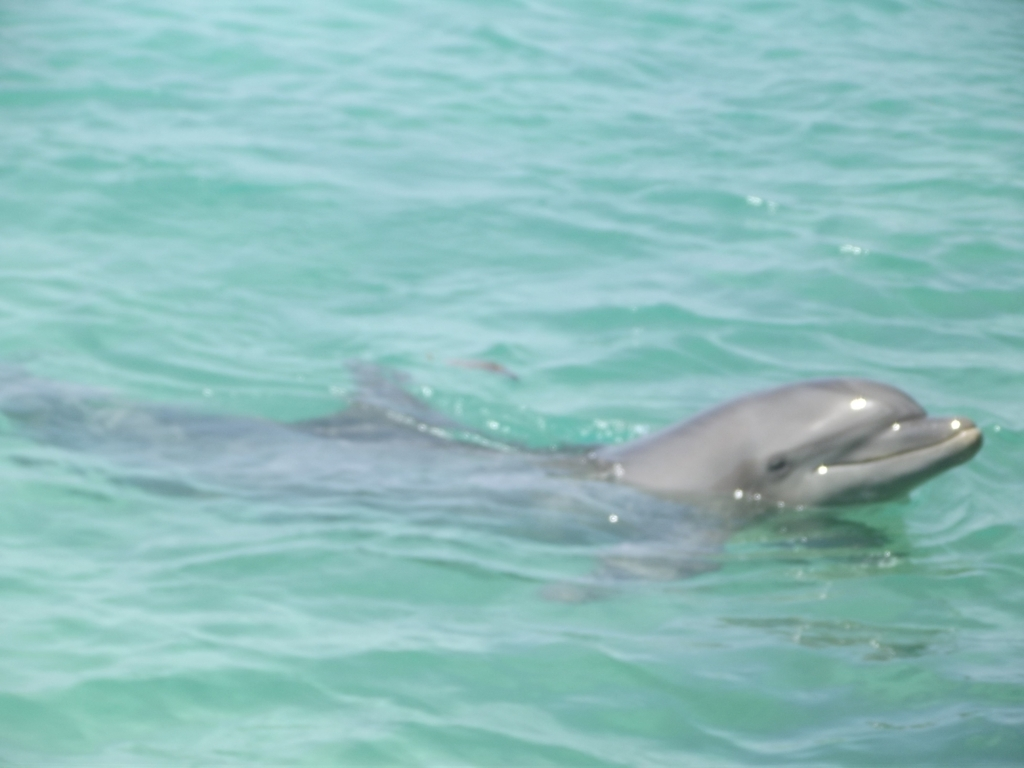Are there any major exposure issues in the photo? The image appears somewhat overexposed with a slight lack of focus, particularly noticeable around the dolphin and the water's surface which causes a slight washout in detail. The overall composition is still pleasant, but a careful balance of exposure settings could have sharpened the details and colors. 